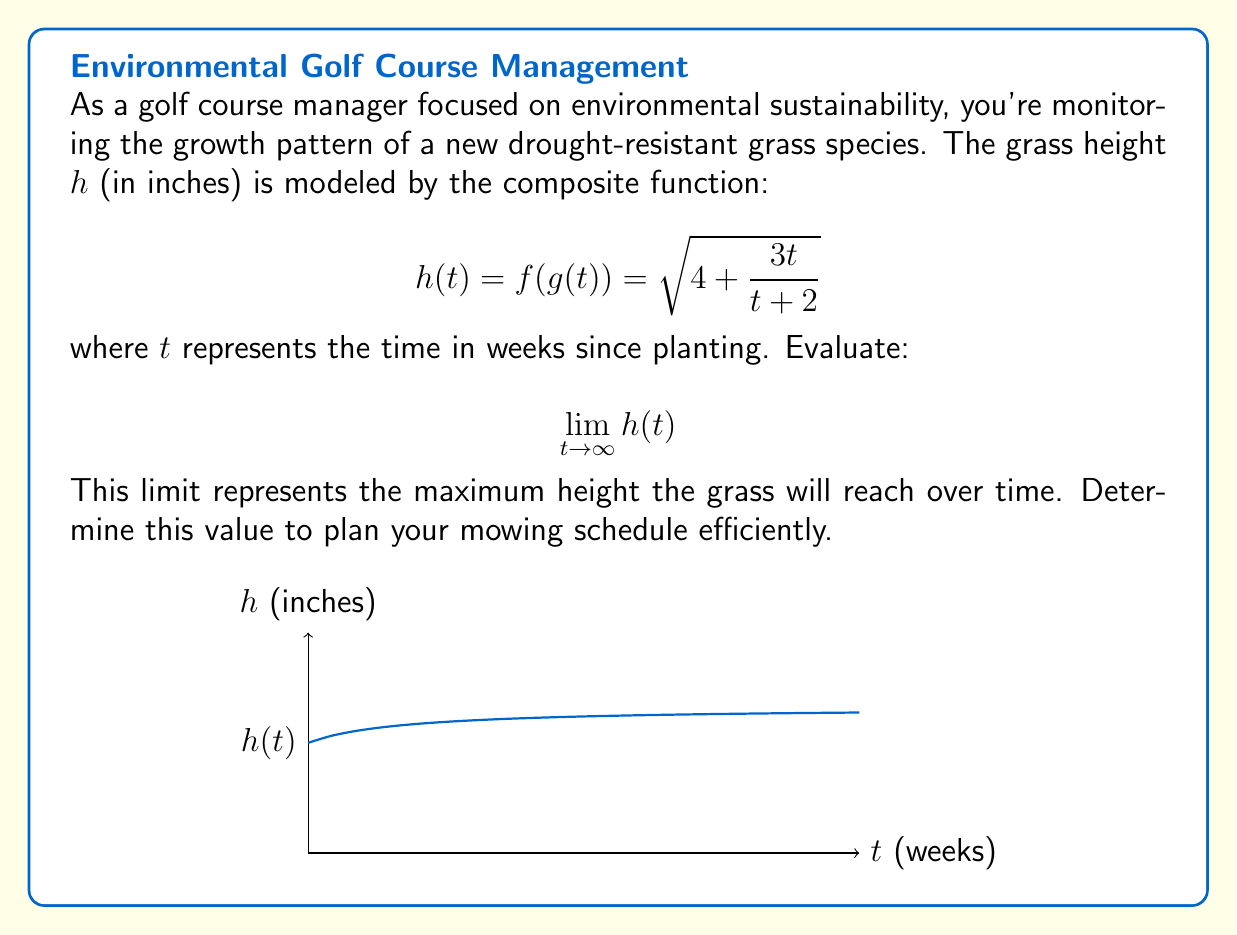Help me with this question. To evaluate this limit, let's follow these steps:

1) First, we need to examine the inner function $g(t) = \frac{3t}{t+2}$. As $t$ approaches infinity, both the numerator and denominator grow, so we need to analyze their behavior:

   $$\lim_{t \to \infty} \frac{3t}{t+2} = \lim_{t \to \infty} \frac{3}{1+\frac{2}{t}} = 3$$

2) Now, we can rewrite our original limit:

   $$\lim_{t \to \infty} h(t) = \lim_{t \to \infty} \sqrt{4 + \frac{3t}{t+2}} = \sqrt{4 + \lim_{t \to \infty} \frac{3t}{t+2}}$$

3) Substituting the result from step 1:

   $$\sqrt{4 + \lim_{t \to \infty} \frac{3t}{t+2}} = \sqrt{4 + 3} = \sqrt{7}$$

4) Therefore, the maximum height the grass will reach is $\sqrt{7}$ inches.
Answer: $\sqrt{7}$ inches 